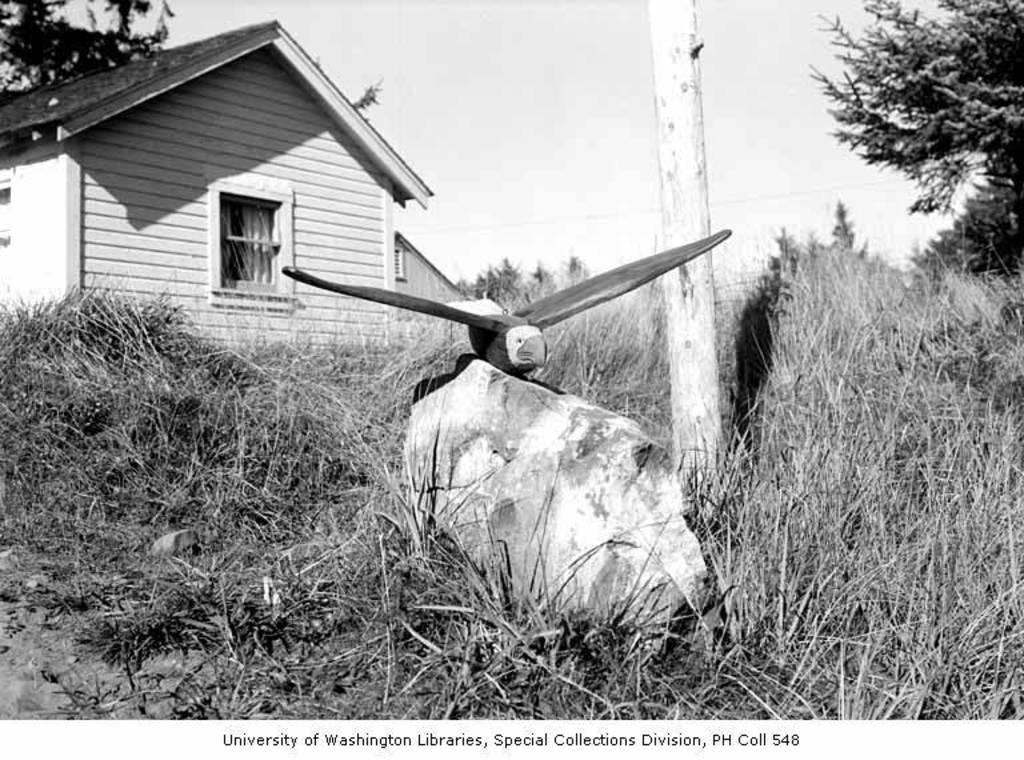What school does this photo belong to?
Your answer should be compact. University of washington. 